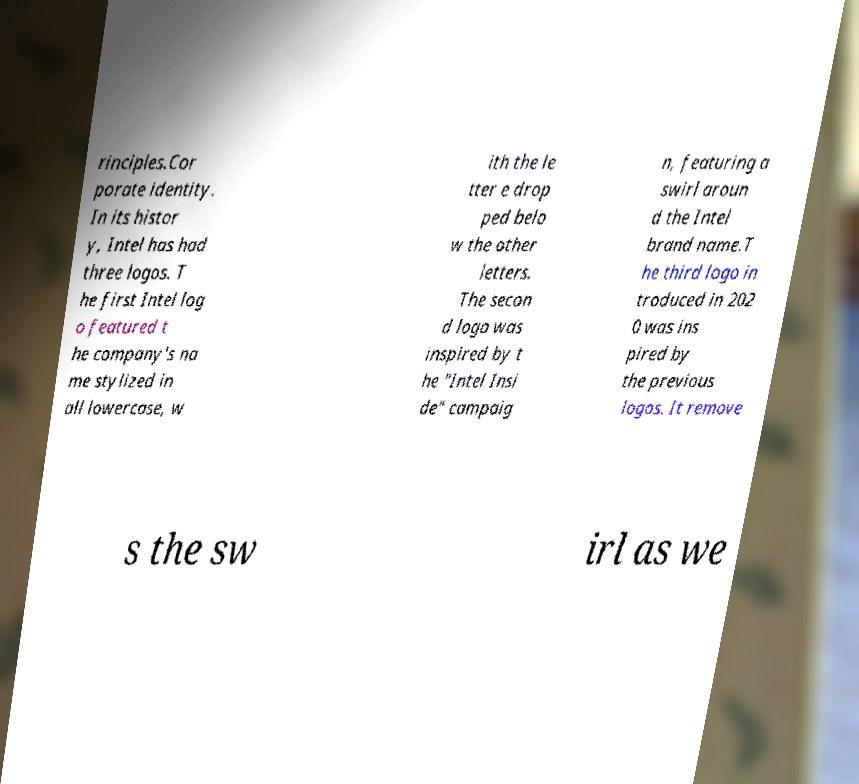For documentation purposes, I need the text within this image transcribed. Could you provide that? rinciples.Cor porate identity. In its histor y, Intel has had three logos. T he first Intel log o featured t he company's na me stylized in all lowercase, w ith the le tter e drop ped belo w the other letters. The secon d logo was inspired by t he "Intel Insi de" campaig n, featuring a swirl aroun d the Intel brand name.T he third logo in troduced in 202 0 was ins pired by the previous logos. It remove s the sw irl as we 